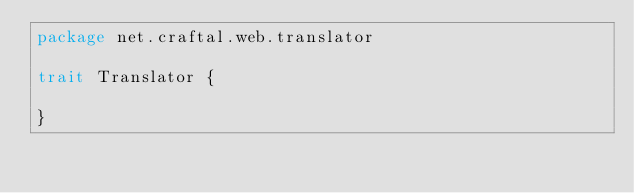Convert code to text. <code><loc_0><loc_0><loc_500><loc_500><_Scala_>package net.craftal.web.translator

trait Translator {

}
</code> 